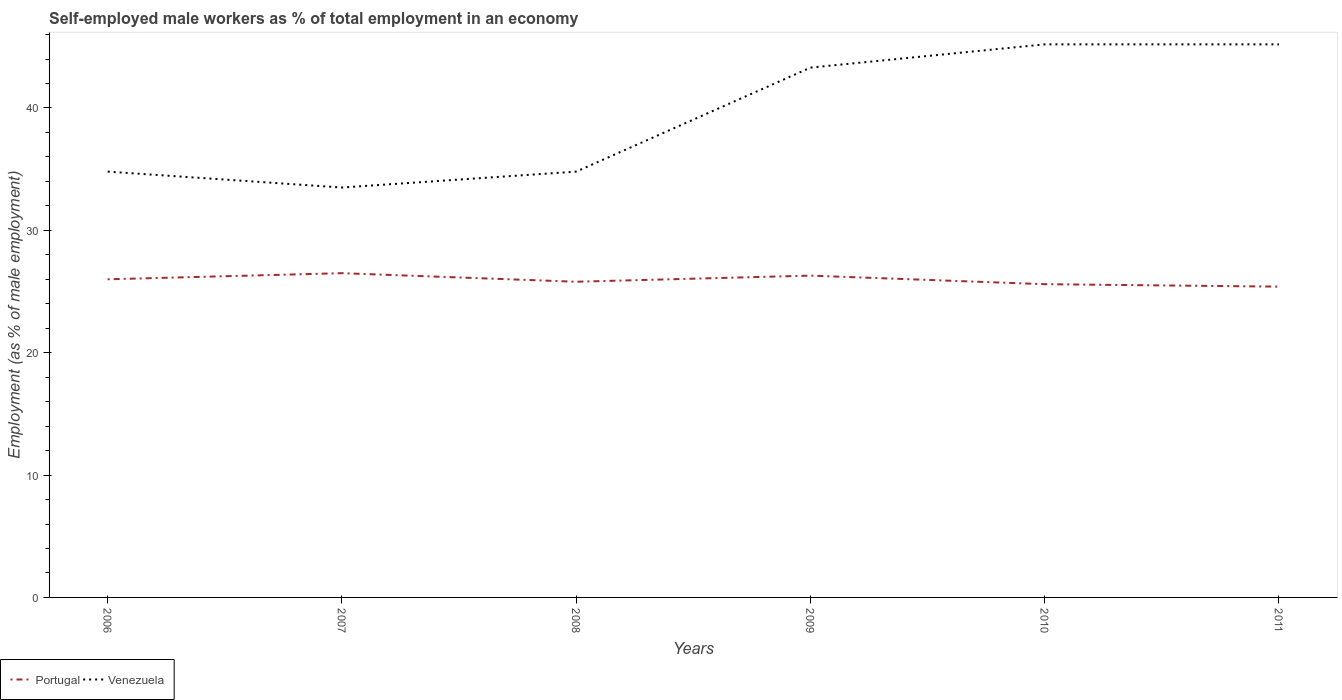Is the number of lines equal to the number of legend labels?
Offer a terse response. Yes. Across all years, what is the maximum percentage of self-employed male workers in Portugal?
Provide a succinct answer. 25.4. In which year was the percentage of self-employed male workers in Portugal maximum?
Offer a terse response. 2011. What is the total percentage of self-employed male workers in Venezuela in the graph?
Your answer should be very brief. -1.9. What is the difference between the highest and the second highest percentage of self-employed male workers in Venezuela?
Offer a terse response. 11.7. How many lines are there?
Provide a short and direct response. 2. Does the graph contain any zero values?
Ensure brevity in your answer.  No. Does the graph contain grids?
Your response must be concise. No. Where does the legend appear in the graph?
Your answer should be compact. Bottom left. How many legend labels are there?
Offer a terse response. 2. What is the title of the graph?
Provide a succinct answer. Self-employed male workers as % of total employment in an economy. Does "Eritrea" appear as one of the legend labels in the graph?
Give a very brief answer. No. What is the label or title of the Y-axis?
Offer a very short reply. Employment (as % of male employment). What is the Employment (as % of male employment) of Portugal in 2006?
Ensure brevity in your answer.  26. What is the Employment (as % of male employment) of Venezuela in 2006?
Ensure brevity in your answer.  34.8. What is the Employment (as % of male employment) in Venezuela in 2007?
Your response must be concise. 33.5. What is the Employment (as % of male employment) in Portugal in 2008?
Make the answer very short. 25.8. What is the Employment (as % of male employment) in Venezuela in 2008?
Your answer should be compact. 34.8. What is the Employment (as % of male employment) of Portugal in 2009?
Provide a short and direct response. 26.3. What is the Employment (as % of male employment) in Venezuela in 2009?
Your answer should be compact. 43.3. What is the Employment (as % of male employment) in Portugal in 2010?
Your answer should be compact. 25.6. What is the Employment (as % of male employment) in Venezuela in 2010?
Offer a very short reply. 45.2. What is the Employment (as % of male employment) in Portugal in 2011?
Your response must be concise. 25.4. What is the Employment (as % of male employment) in Venezuela in 2011?
Your answer should be very brief. 45.2. Across all years, what is the maximum Employment (as % of male employment) of Venezuela?
Provide a short and direct response. 45.2. Across all years, what is the minimum Employment (as % of male employment) of Portugal?
Provide a short and direct response. 25.4. Across all years, what is the minimum Employment (as % of male employment) in Venezuela?
Offer a very short reply. 33.5. What is the total Employment (as % of male employment) in Portugal in the graph?
Give a very brief answer. 155.6. What is the total Employment (as % of male employment) in Venezuela in the graph?
Provide a short and direct response. 236.8. What is the difference between the Employment (as % of male employment) in Portugal in 2006 and that in 2007?
Provide a short and direct response. -0.5. What is the difference between the Employment (as % of male employment) of Venezuela in 2006 and that in 2007?
Offer a very short reply. 1.3. What is the difference between the Employment (as % of male employment) in Venezuela in 2006 and that in 2008?
Give a very brief answer. 0. What is the difference between the Employment (as % of male employment) of Portugal in 2006 and that in 2009?
Keep it short and to the point. -0.3. What is the difference between the Employment (as % of male employment) in Portugal in 2006 and that in 2011?
Keep it short and to the point. 0.6. What is the difference between the Employment (as % of male employment) in Venezuela in 2006 and that in 2011?
Provide a short and direct response. -10.4. What is the difference between the Employment (as % of male employment) of Portugal in 2007 and that in 2008?
Ensure brevity in your answer.  0.7. What is the difference between the Employment (as % of male employment) in Portugal in 2007 and that in 2009?
Provide a succinct answer. 0.2. What is the difference between the Employment (as % of male employment) of Portugal in 2007 and that in 2010?
Offer a terse response. 0.9. What is the difference between the Employment (as % of male employment) of Venezuela in 2007 and that in 2011?
Provide a succinct answer. -11.7. What is the difference between the Employment (as % of male employment) of Portugal in 2008 and that in 2009?
Ensure brevity in your answer.  -0.5. What is the difference between the Employment (as % of male employment) of Venezuela in 2008 and that in 2009?
Make the answer very short. -8.5. What is the difference between the Employment (as % of male employment) in Portugal in 2008 and that in 2010?
Your answer should be very brief. 0.2. What is the difference between the Employment (as % of male employment) of Venezuela in 2008 and that in 2010?
Offer a very short reply. -10.4. What is the difference between the Employment (as % of male employment) in Portugal in 2008 and that in 2011?
Make the answer very short. 0.4. What is the difference between the Employment (as % of male employment) of Venezuela in 2009 and that in 2010?
Provide a short and direct response. -1.9. What is the difference between the Employment (as % of male employment) of Portugal in 2006 and the Employment (as % of male employment) of Venezuela in 2007?
Provide a short and direct response. -7.5. What is the difference between the Employment (as % of male employment) in Portugal in 2006 and the Employment (as % of male employment) in Venezuela in 2009?
Your answer should be compact. -17.3. What is the difference between the Employment (as % of male employment) in Portugal in 2006 and the Employment (as % of male employment) in Venezuela in 2010?
Make the answer very short. -19.2. What is the difference between the Employment (as % of male employment) in Portugal in 2006 and the Employment (as % of male employment) in Venezuela in 2011?
Keep it short and to the point. -19.2. What is the difference between the Employment (as % of male employment) in Portugal in 2007 and the Employment (as % of male employment) in Venezuela in 2009?
Ensure brevity in your answer.  -16.8. What is the difference between the Employment (as % of male employment) of Portugal in 2007 and the Employment (as % of male employment) of Venezuela in 2010?
Offer a terse response. -18.7. What is the difference between the Employment (as % of male employment) in Portugal in 2007 and the Employment (as % of male employment) in Venezuela in 2011?
Make the answer very short. -18.7. What is the difference between the Employment (as % of male employment) in Portugal in 2008 and the Employment (as % of male employment) in Venezuela in 2009?
Make the answer very short. -17.5. What is the difference between the Employment (as % of male employment) of Portugal in 2008 and the Employment (as % of male employment) of Venezuela in 2010?
Ensure brevity in your answer.  -19.4. What is the difference between the Employment (as % of male employment) of Portugal in 2008 and the Employment (as % of male employment) of Venezuela in 2011?
Ensure brevity in your answer.  -19.4. What is the difference between the Employment (as % of male employment) in Portugal in 2009 and the Employment (as % of male employment) in Venezuela in 2010?
Ensure brevity in your answer.  -18.9. What is the difference between the Employment (as % of male employment) in Portugal in 2009 and the Employment (as % of male employment) in Venezuela in 2011?
Offer a very short reply. -18.9. What is the difference between the Employment (as % of male employment) of Portugal in 2010 and the Employment (as % of male employment) of Venezuela in 2011?
Offer a terse response. -19.6. What is the average Employment (as % of male employment) of Portugal per year?
Provide a succinct answer. 25.93. What is the average Employment (as % of male employment) in Venezuela per year?
Provide a succinct answer. 39.47. In the year 2007, what is the difference between the Employment (as % of male employment) of Portugal and Employment (as % of male employment) of Venezuela?
Keep it short and to the point. -7. In the year 2008, what is the difference between the Employment (as % of male employment) in Portugal and Employment (as % of male employment) in Venezuela?
Your response must be concise. -9. In the year 2009, what is the difference between the Employment (as % of male employment) of Portugal and Employment (as % of male employment) of Venezuela?
Your answer should be very brief. -17. In the year 2010, what is the difference between the Employment (as % of male employment) of Portugal and Employment (as % of male employment) of Venezuela?
Give a very brief answer. -19.6. In the year 2011, what is the difference between the Employment (as % of male employment) of Portugal and Employment (as % of male employment) of Venezuela?
Offer a very short reply. -19.8. What is the ratio of the Employment (as % of male employment) in Portugal in 2006 to that in 2007?
Provide a short and direct response. 0.98. What is the ratio of the Employment (as % of male employment) in Venezuela in 2006 to that in 2007?
Keep it short and to the point. 1.04. What is the ratio of the Employment (as % of male employment) in Portugal in 2006 to that in 2008?
Your answer should be very brief. 1.01. What is the ratio of the Employment (as % of male employment) of Venezuela in 2006 to that in 2008?
Provide a succinct answer. 1. What is the ratio of the Employment (as % of male employment) of Venezuela in 2006 to that in 2009?
Provide a succinct answer. 0.8. What is the ratio of the Employment (as % of male employment) of Portugal in 2006 to that in 2010?
Provide a succinct answer. 1.02. What is the ratio of the Employment (as % of male employment) of Venezuela in 2006 to that in 2010?
Offer a terse response. 0.77. What is the ratio of the Employment (as % of male employment) in Portugal in 2006 to that in 2011?
Ensure brevity in your answer.  1.02. What is the ratio of the Employment (as % of male employment) in Venezuela in 2006 to that in 2011?
Your answer should be very brief. 0.77. What is the ratio of the Employment (as % of male employment) of Portugal in 2007 to that in 2008?
Offer a terse response. 1.03. What is the ratio of the Employment (as % of male employment) in Venezuela in 2007 to that in 2008?
Ensure brevity in your answer.  0.96. What is the ratio of the Employment (as % of male employment) of Portugal in 2007 to that in 2009?
Offer a terse response. 1.01. What is the ratio of the Employment (as % of male employment) in Venezuela in 2007 to that in 2009?
Provide a short and direct response. 0.77. What is the ratio of the Employment (as % of male employment) of Portugal in 2007 to that in 2010?
Keep it short and to the point. 1.04. What is the ratio of the Employment (as % of male employment) in Venezuela in 2007 to that in 2010?
Your answer should be very brief. 0.74. What is the ratio of the Employment (as % of male employment) of Portugal in 2007 to that in 2011?
Your response must be concise. 1.04. What is the ratio of the Employment (as % of male employment) of Venezuela in 2007 to that in 2011?
Provide a short and direct response. 0.74. What is the ratio of the Employment (as % of male employment) of Portugal in 2008 to that in 2009?
Provide a succinct answer. 0.98. What is the ratio of the Employment (as % of male employment) of Venezuela in 2008 to that in 2009?
Your answer should be very brief. 0.8. What is the ratio of the Employment (as % of male employment) of Portugal in 2008 to that in 2010?
Your response must be concise. 1.01. What is the ratio of the Employment (as % of male employment) of Venezuela in 2008 to that in 2010?
Keep it short and to the point. 0.77. What is the ratio of the Employment (as % of male employment) of Portugal in 2008 to that in 2011?
Give a very brief answer. 1.02. What is the ratio of the Employment (as % of male employment) of Venezuela in 2008 to that in 2011?
Make the answer very short. 0.77. What is the ratio of the Employment (as % of male employment) in Portugal in 2009 to that in 2010?
Offer a very short reply. 1.03. What is the ratio of the Employment (as % of male employment) in Venezuela in 2009 to that in 2010?
Your answer should be compact. 0.96. What is the ratio of the Employment (as % of male employment) of Portugal in 2009 to that in 2011?
Make the answer very short. 1.04. What is the ratio of the Employment (as % of male employment) in Venezuela in 2009 to that in 2011?
Give a very brief answer. 0.96. What is the ratio of the Employment (as % of male employment) of Portugal in 2010 to that in 2011?
Make the answer very short. 1.01. What is the ratio of the Employment (as % of male employment) in Venezuela in 2010 to that in 2011?
Keep it short and to the point. 1. What is the difference between the highest and the second highest Employment (as % of male employment) of Portugal?
Offer a very short reply. 0.2. 